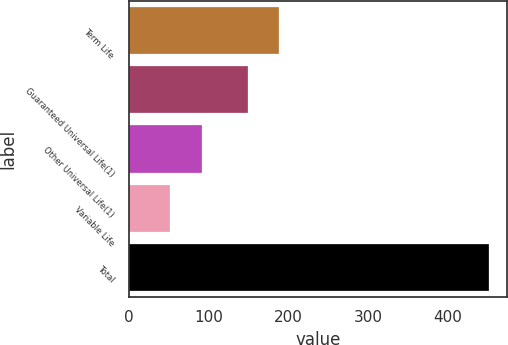<chart> <loc_0><loc_0><loc_500><loc_500><bar_chart><fcel>Term Life<fcel>Guaranteed Universal Life(1)<fcel>Other Universal Life(1)<fcel>Variable Life<fcel>Total<nl><fcel>189<fcel>149<fcel>92<fcel>52<fcel>452<nl></chart> 